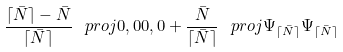<formula> <loc_0><loc_0><loc_500><loc_500>\frac { \lceil \bar { N } \rceil - \bar { N } } { \lceil \bar { N } \rceil } \, \ p r o j { 0 , 0 } { 0 , 0 } + \frac { \bar { N } } { \lceil \bar { N } \rceil } \, \ p r o j { \Psi _ { \lceil \bar { N } \rceil } } { \Psi _ { \lceil \bar { N } \rceil } }</formula> 